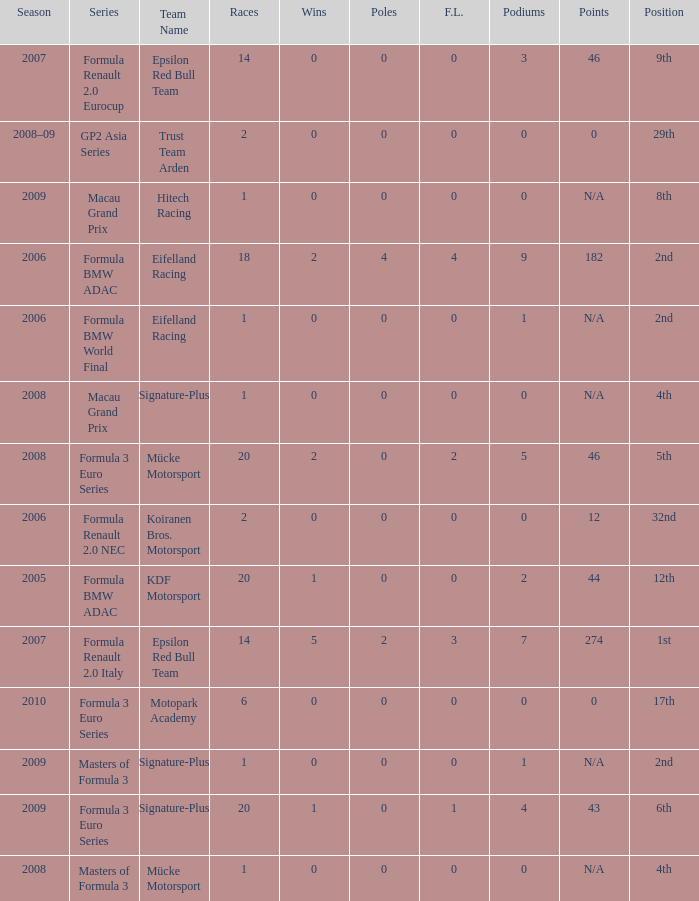What is the race in the 8th position? 1.0. 